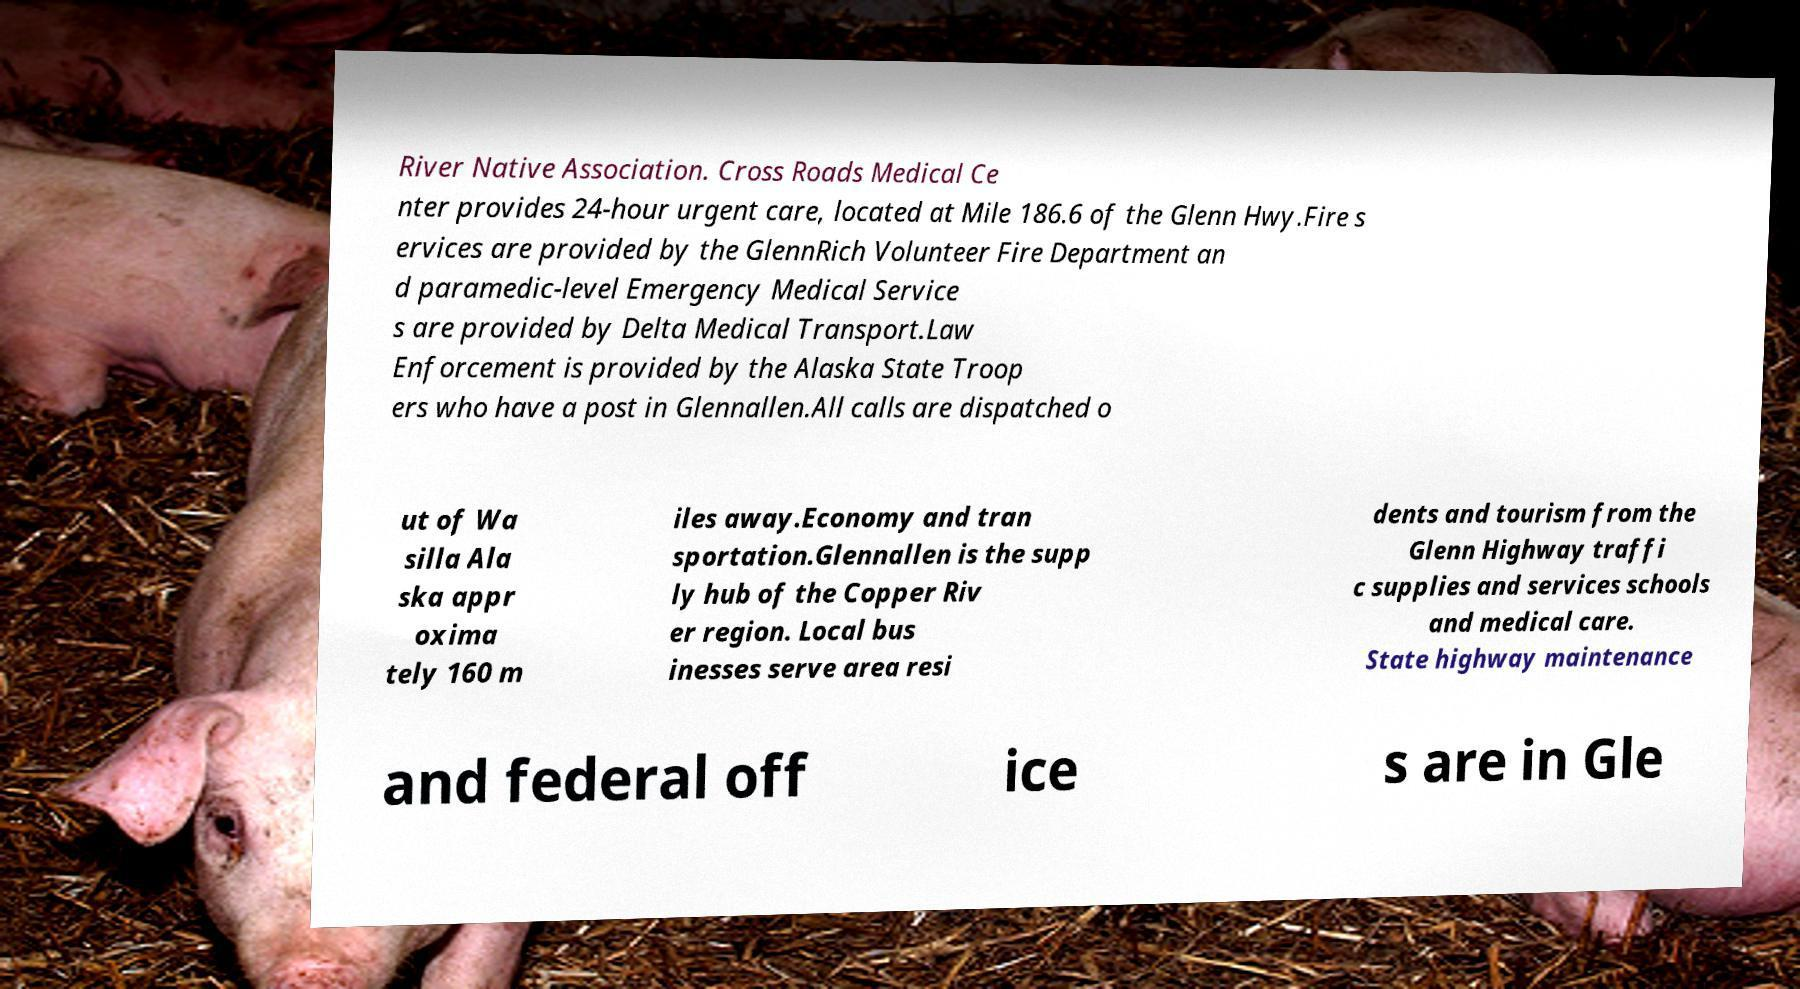Can you accurately transcribe the text from the provided image for me? River Native Association. Cross Roads Medical Ce nter provides 24-hour urgent care, located at Mile 186.6 of the Glenn Hwy.Fire s ervices are provided by the GlennRich Volunteer Fire Department an d paramedic-level Emergency Medical Service s are provided by Delta Medical Transport.Law Enforcement is provided by the Alaska State Troop ers who have a post in Glennallen.All calls are dispatched o ut of Wa silla Ala ska appr oxima tely 160 m iles away.Economy and tran sportation.Glennallen is the supp ly hub of the Copper Riv er region. Local bus inesses serve area resi dents and tourism from the Glenn Highway traffi c supplies and services schools and medical care. State highway maintenance and federal off ice s are in Gle 